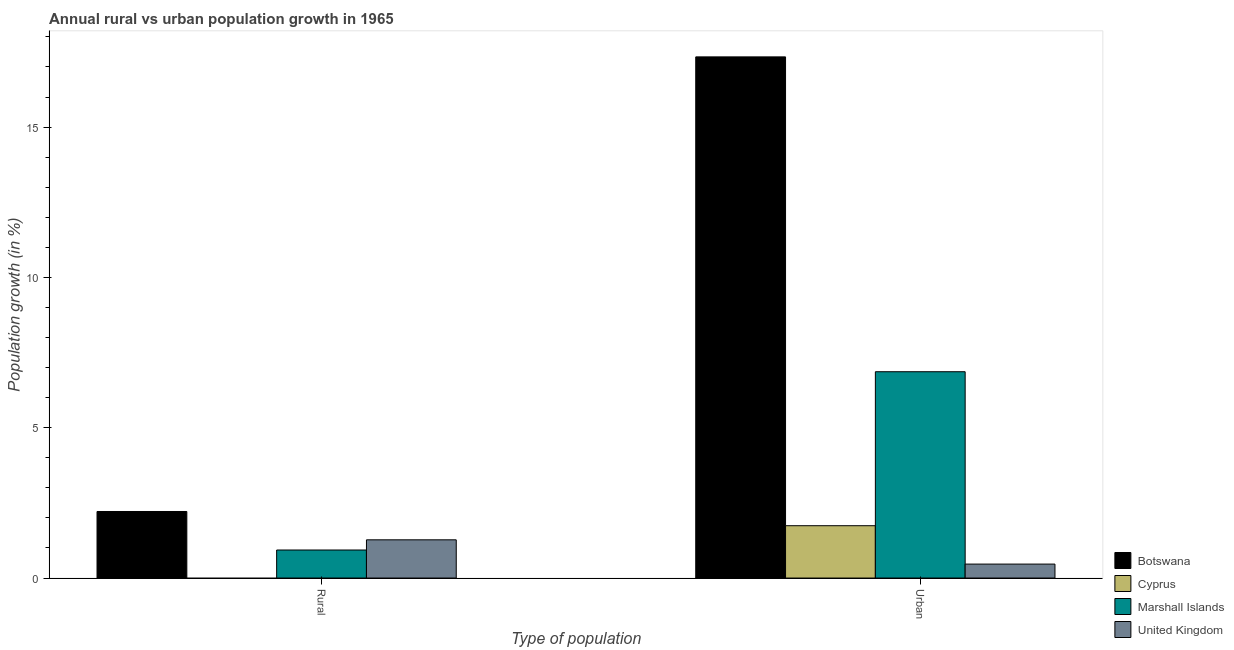How many bars are there on the 2nd tick from the left?
Your answer should be very brief. 4. What is the label of the 1st group of bars from the left?
Make the answer very short. Rural. What is the urban population growth in Cyprus?
Your answer should be very brief. 1.74. Across all countries, what is the maximum urban population growth?
Your answer should be very brief. 17.34. Across all countries, what is the minimum rural population growth?
Offer a very short reply. 0. In which country was the rural population growth maximum?
Provide a short and direct response. Botswana. What is the total urban population growth in the graph?
Provide a short and direct response. 26.4. What is the difference between the urban population growth in Cyprus and that in Marshall Islands?
Offer a very short reply. -5.12. What is the difference between the rural population growth in Botswana and the urban population growth in Cyprus?
Offer a terse response. 0.47. What is the average urban population growth per country?
Give a very brief answer. 6.6. What is the difference between the rural population growth and urban population growth in Botswana?
Provide a succinct answer. -15.12. What is the ratio of the rural population growth in Marshall Islands to that in United Kingdom?
Make the answer very short. 0.73. How many bars are there?
Offer a very short reply. 7. Are all the bars in the graph horizontal?
Offer a terse response. No. What is the difference between two consecutive major ticks on the Y-axis?
Give a very brief answer. 5. Where does the legend appear in the graph?
Offer a very short reply. Bottom right. How many legend labels are there?
Give a very brief answer. 4. How are the legend labels stacked?
Provide a succinct answer. Vertical. What is the title of the graph?
Ensure brevity in your answer.  Annual rural vs urban population growth in 1965. Does "Austria" appear as one of the legend labels in the graph?
Provide a short and direct response. No. What is the label or title of the X-axis?
Ensure brevity in your answer.  Type of population. What is the label or title of the Y-axis?
Offer a very short reply. Population growth (in %). What is the Population growth (in %) of Botswana in Rural?
Your answer should be very brief. 2.21. What is the Population growth (in %) in Cyprus in Rural?
Provide a succinct answer. 0. What is the Population growth (in %) in Marshall Islands in Rural?
Provide a short and direct response. 0.93. What is the Population growth (in %) in United Kingdom in Rural?
Provide a succinct answer. 1.27. What is the Population growth (in %) in Botswana in Urban ?
Offer a very short reply. 17.34. What is the Population growth (in %) of Cyprus in Urban ?
Keep it short and to the point. 1.74. What is the Population growth (in %) of Marshall Islands in Urban ?
Provide a succinct answer. 6.86. What is the Population growth (in %) in United Kingdom in Urban ?
Your answer should be compact. 0.46. Across all Type of population, what is the maximum Population growth (in %) in Botswana?
Make the answer very short. 17.34. Across all Type of population, what is the maximum Population growth (in %) of Cyprus?
Give a very brief answer. 1.74. Across all Type of population, what is the maximum Population growth (in %) of Marshall Islands?
Your response must be concise. 6.86. Across all Type of population, what is the maximum Population growth (in %) in United Kingdom?
Keep it short and to the point. 1.27. Across all Type of population, what is the minimum Population growth (in %) in Botswana?
Offer a terse response. 2.21. Across all Type of population, what is the minimum Population growth (in %) of Marshall Islands?
Provide a succinct answer. 0.93. Across all Type of population, what is the minimum Population growth (in %) in United Kingdom?
Ensure brevity in your answer.  0.46. What is the total Population growth (in %) of Botswana in the graph?
Give a very brief answer. 19.55. What is the total Population growth (in %) in Cyprus in the graph?
Your response must be concise. 1.74. What is the total Population growth (in %) in Marshall Islands in the graph?
Provide a short and direct response. 7.8. What is the total Population growth (in %) in United Kingdom in the graph?
Provide a succinct answer. 1.74. What is the difference between the Population growth (in %) of Botswana in Rural and that in Urban ?
Your answer should be very brief. -15.12. What is the difference between the Population growth (in %) of Marshall Islands in Rural and that in Urban ?
Your answer should be compact. -5.93. What is the difference between the Population growth (in %) of United Kingdom in Rural and that in Urban ?
Ensure brevity in your answer.  0.81. What is the difference between the Population growth (in %) of Botswana in Rural and the Population growth (in %) of Cyprus in Urban?
Provide a succinct answer. 0.47. What is the difference between the Population growth (in %) in Botswana in Rural and the Population growth (in %) in Marshall Islands in Urban?
Your response must be concise. -4.65. What is the difference between the Population growth (in %) in Botswana in Rural and the Population growth (in %) in United Kingdom in Urban?
Give a very brief answer. 1.75. What is the difference between the Population growth (in %) of Marshall Islands in Rural and the Population growth (in %) of United Kingdom in Urban?
Your answer should be very brief. 0.47. What is the average Population growth (in %) of Botswana per Type of population?
Ensure brevity in your answer.  9.77. What is the average Population growth (in %) of Cyprus per Type of population?
Ensure brevity in your answer.  0.87. What is the average Population growth (in %) in Marshall Islands per Type of population?
Provide a succinct answer. 3.9. What is the average Population growth (in %) in United Kingdom per Type of population?
Keep it short and to the point. 0.87. What is the difference between the Population growth (in %) of Botswana and Population growth (in %) of Marshall Islands in Rural?
Offer a terse response. 1.28. What is the difference between the Population growth (in %) of Botswana and Population growth (in %) of United Kingdom in Rural?
Provide a succinct answer. 0.94. What is the difference between the Population growth (in %) of Marshall Islands and Population growth (in %) of United Kingdom in Rural?
Your answer should be compact. -0.34. What is the difference between the Population growth (in %) of Botswana and Population growth (in %) of Cyprus in Urban ?
Keep it short and to the point. 15.6. What is the difference between the Population growth (in %) of Botswana and Population growth (in %) of Marshall Islands in Urban ?
Provide a succinct answer. 10.47. What is the difference between the Population growth (in %) of Botswana and Population growth (in %) of United Kingdom in Urban ?
Provide a short and direct response. 16.87. What is the difference between the Population growth (in %) of Cyprus and Population growth (in %) of Marshall Islands in Urban ?
Your answer should be compact. -5.12. What is the difference between the Population growth (in %) of Cyprus and Population growth (in %) of United Kingdom in Urban ?
Offer a terse response. 1.28. What is the difference between the Population growth (in %) of Marshall Islands and Population growth (in %) of United Kingdom in Urban ?
Offer a very short reply. 6.4. What is the ratio of the Population growth (in %) of Botswana in Rural to that in Urban ?
Your response must be concise. 0.13. What is the ratio of the Population growth (in %) in Marshall Islands in Rural to that in Urban ?
Make the answer very short. 0.14. What is the ratio of the Population growth (in %) of United Kingdom in Rural to that in Urban ?
Offer a very short reply. 2.74. What is the difference between the highest and the second highest Population growth (in %) in Botswana?
Your response must be concise. 15.12. What is the difference between the highest and the second highest Population growth (in %) in Marshall Islands?
Offer a very short reply. 5.93. What is the difference between the highest and the second highest Population growth (in %) of United Kingdom?
Provide a succinct answer. 0.81. What is the difference between the highest and the lowest Population growth (in %) of Botswana?
Ensure brevity in your answer.  15.12. What is the difference between the highest and the lowest Population growth (in %) in Cyprus?
Make the answer very short. 1.74. What is the difference between the highest and the lowest Population growth (in %) in Marshall Islands?
Your response must be concise. 5.93. What is the difference between the highest and the lowest Population growth (in %) in United Kingdom?
Your response must be concise. 0.81. 